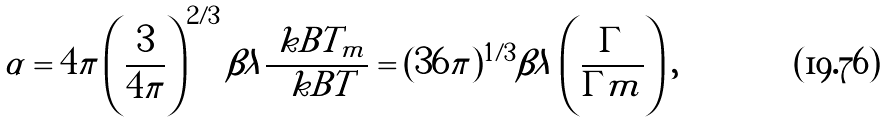Convert formula to latex. <formula><loc_0><loc_0><loc_500><loc_500>\alpha = 4 \pi \left ( \frac { 3 } { 4 \pi } \right ) ^ { 2 / 3 } \beta \lambda \frac { \ k B T _ { m } } { \ k B T } = ( 3 6 \pi ) ^ { 1 / 3 } \beta \lambda \left ( \frac { \Gamma } { \Gamma m } \right ) ,</formula> 